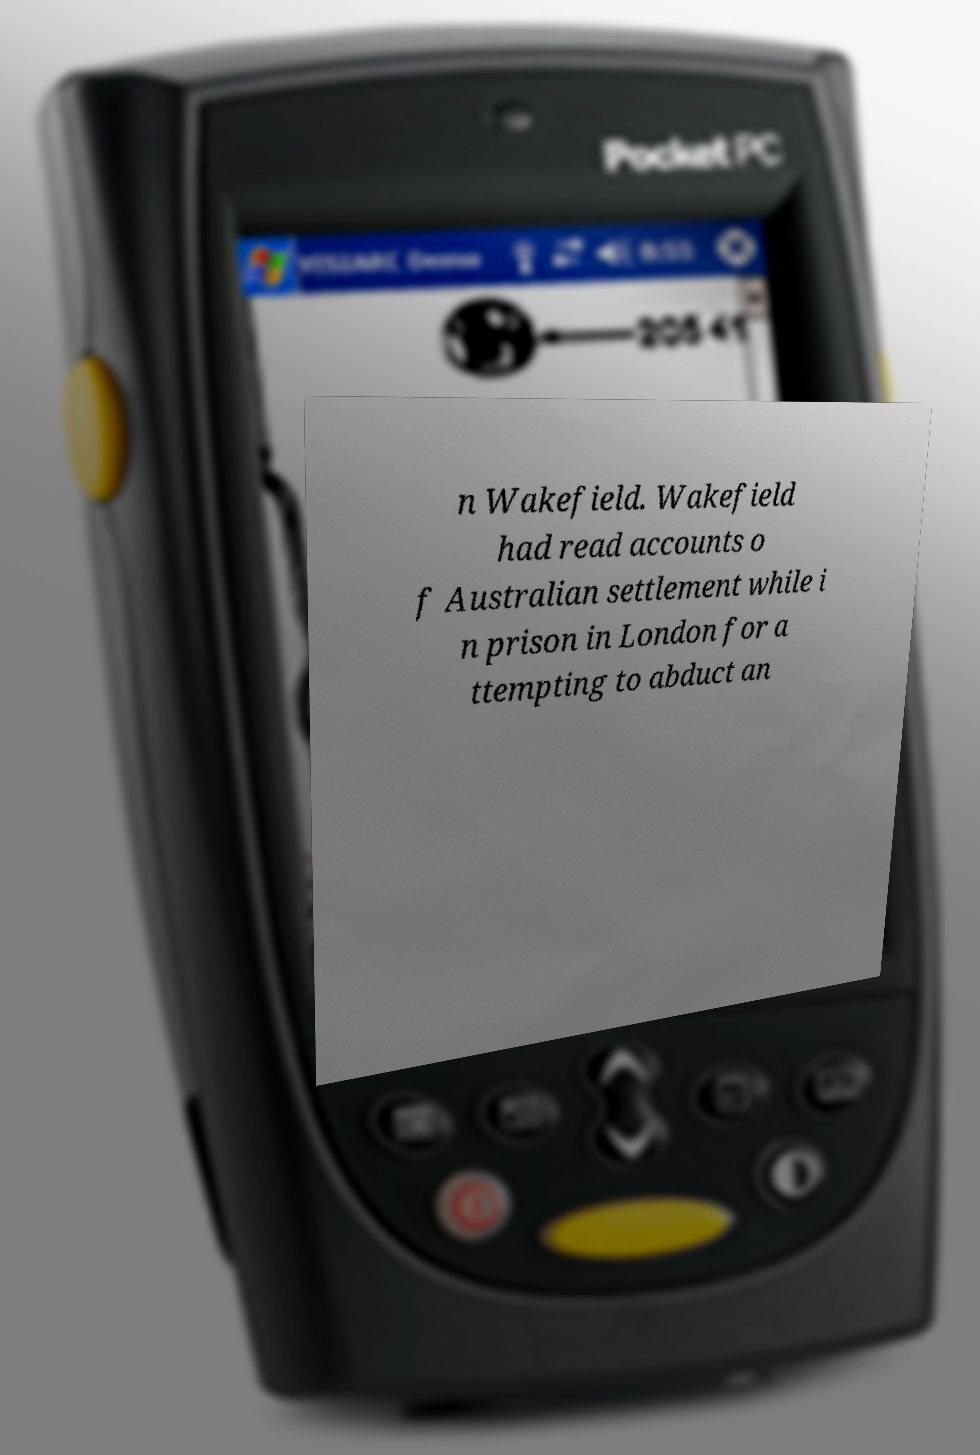Can you accurately transcribe the text from the provided image for me? n Wakefield. Wakefield had read accounts o f Australian settlement while i n prison in London for a ttempting to abduct an 